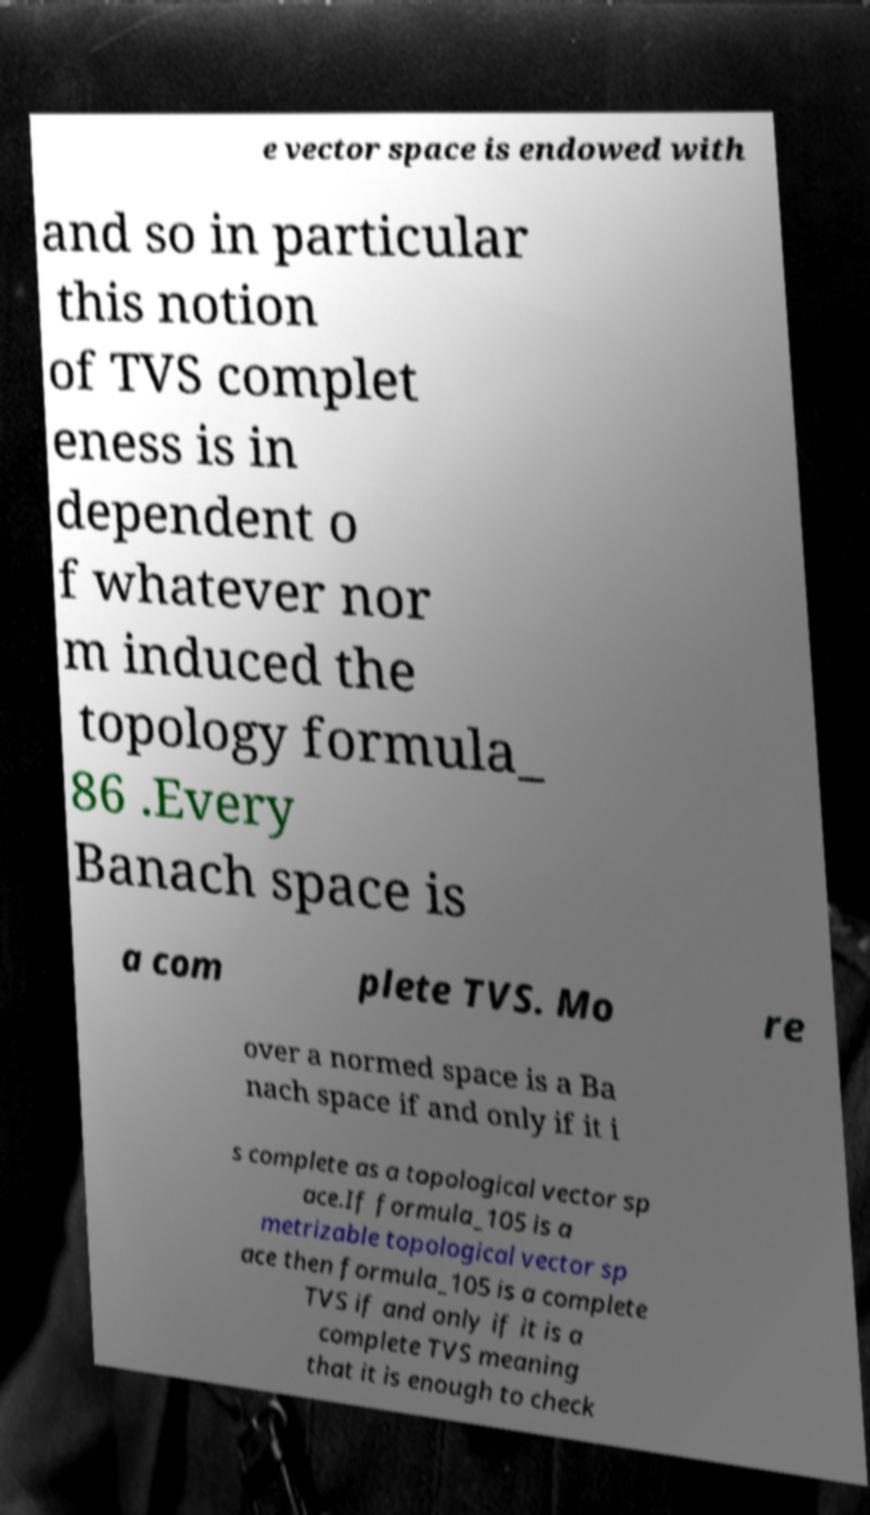Please read and relay the text visible in this image. What does it say? e vector space is endowed with and so in particular this notion of TVS complet eness is in dependent o f whatever nor m induced the topology formula_ 86 .Every Banach space is a com plete TVS. Mo re over a normed space is a Ba nach space if and only if it i s complete as a topological vector sp ace.If formula_105 is a metrizable topological vector sp ace then formula_105 is a complete TVS if and only if it is a complete TVS meaning that it is enough to check 